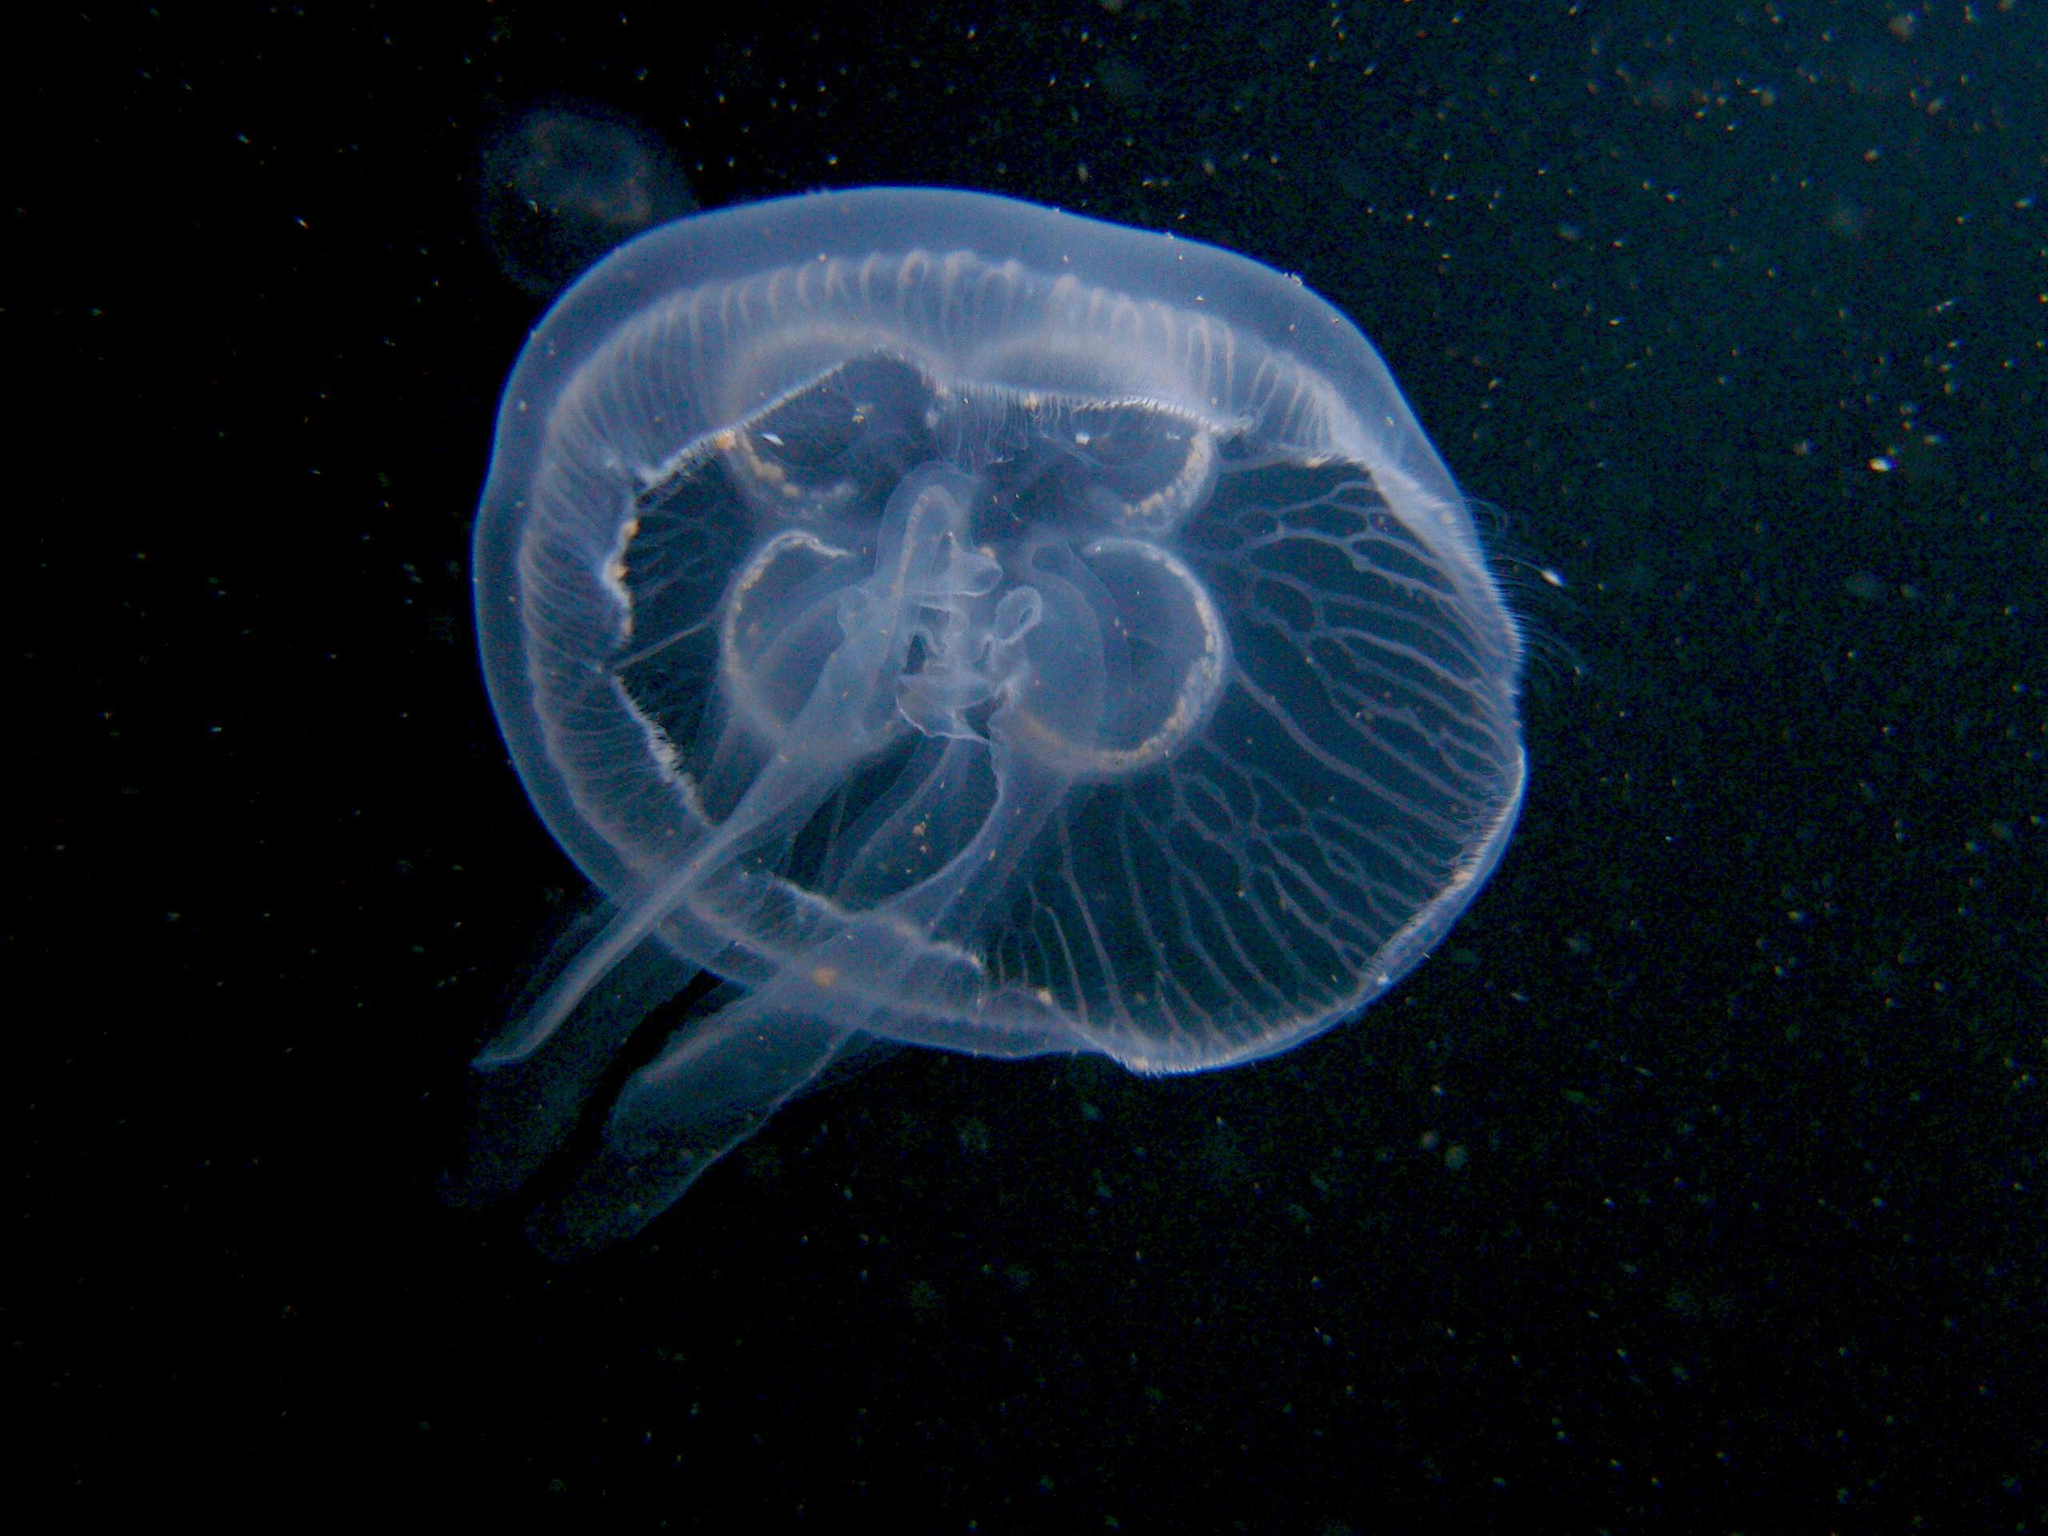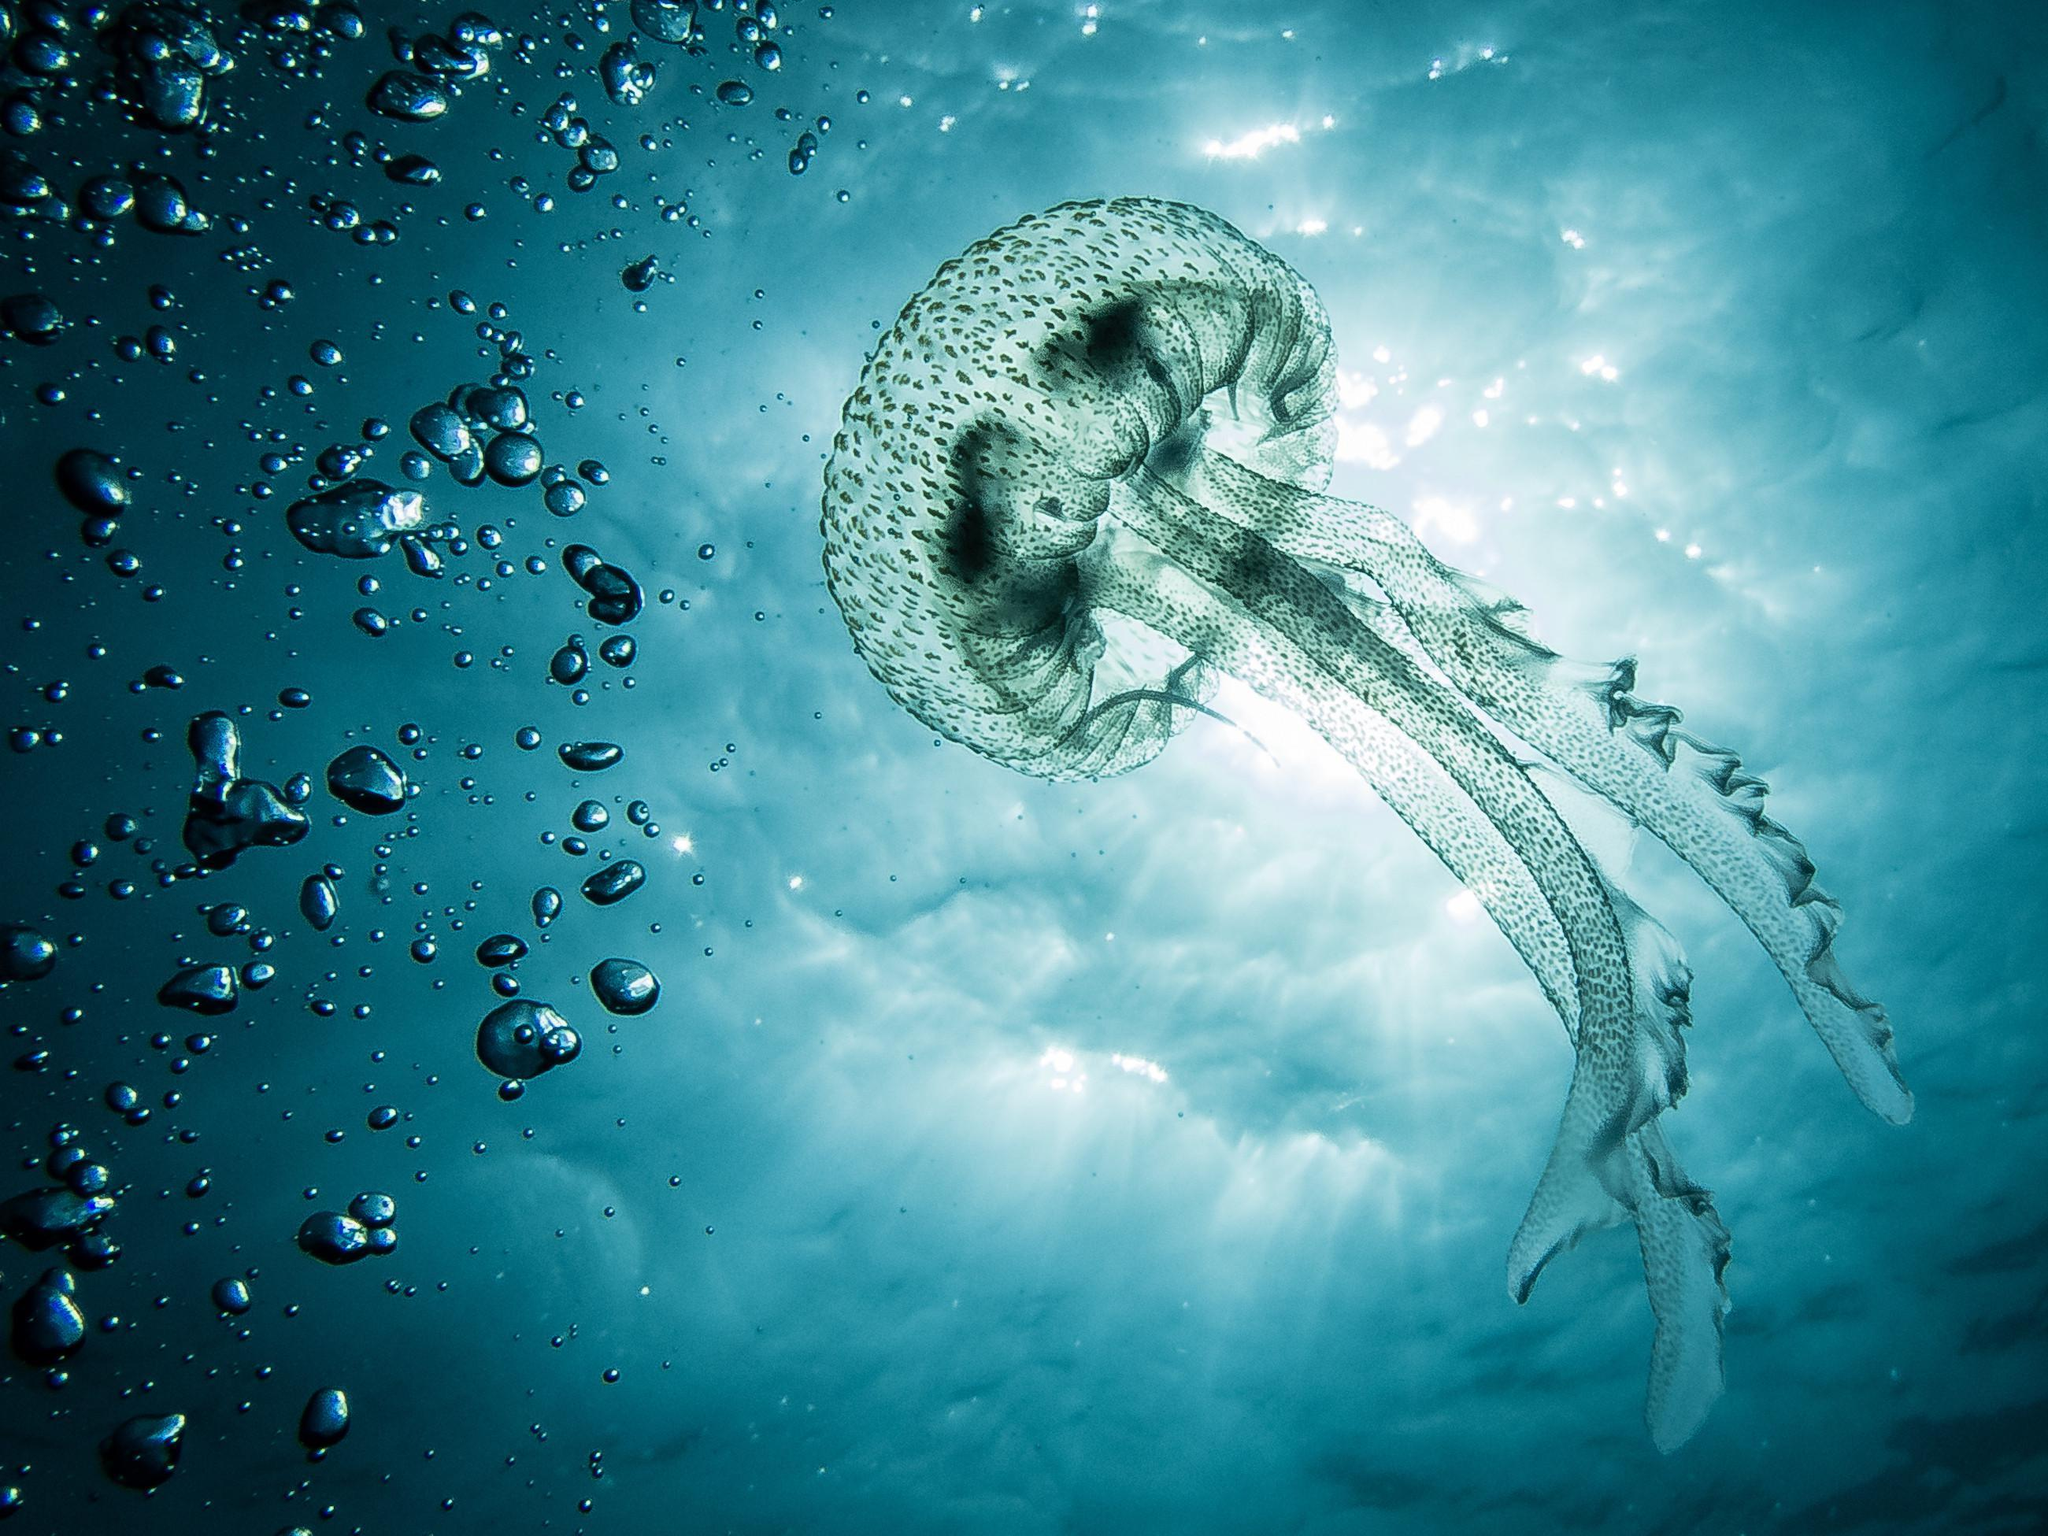The first image is the image on the left, the second image is the image on the right. For the images displayed, is the sentence "The foreground of an image shows one pale, translucent, saucer-shaped jellyfish without long tendrils." factually correct? Answer yes or no. Yes. The first image is the image on the left, the second image is the image on the right. Analyze the images presented: Is the assertion "One image shows one or more jellyfish with short tentacles, while the other shows a single jellyfish with long tentacles." valid? Answer yes or no. Yes. 